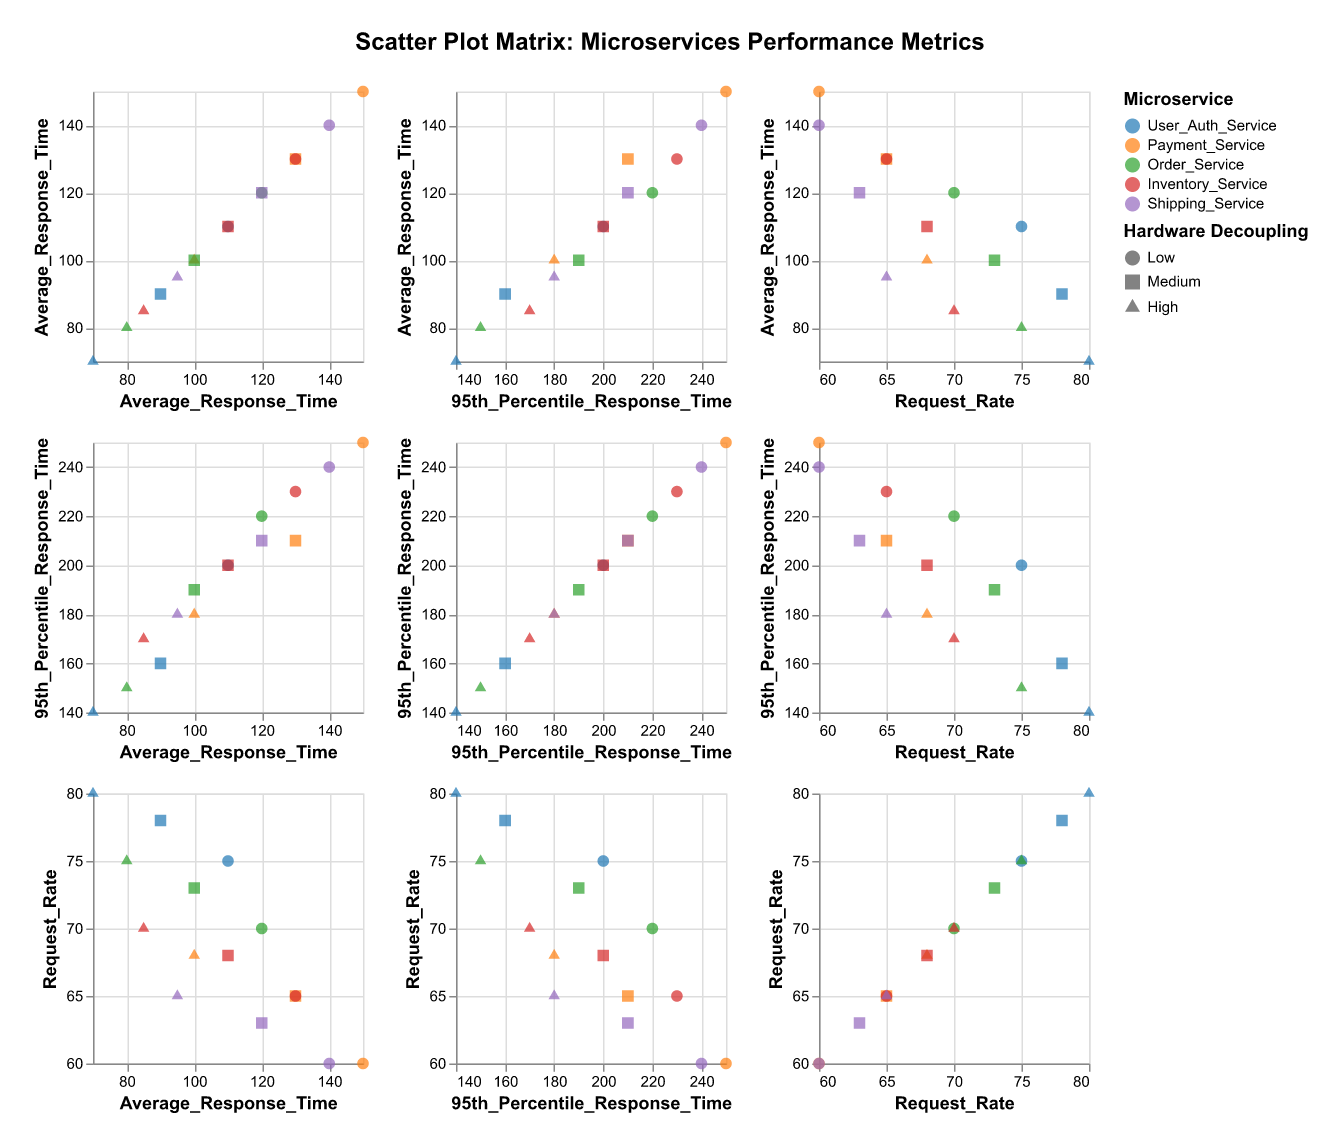What is the title of the scatter plot matrix? The title can be found at the top of the figure.
Answer: Scatter Plot Matrix: Microservices Performance Metrics Which microservice tends to have the highest average response times across different levels of hardware decoupling? By observing the scatter points for the average response time, Payment_Service generally has higher values compared to others.
Answer: Payment_Service How does the 95th percentile response time change for User_Auth_Service with increased hardware decoupling? For User_Auth_Service, observe how the 95th percentile response time points change from the "Low" to "High" decoupling levels. The visual trend shows decreasing values.
Answer: It decreases Which service demonstrates the greatest reduction in average response time from low to high hardware decoupling? Compute the difference in average response time for each service between "Low" and "High" decoupling levels. Payment_Service shows the biggest reduction (150 - 100 = 50 ms).
Answer: Payment_Service How does the request rate trend with hardware decoupling levels for Shipping_Service? Look at the shape (circle, square, triangle) and color in the request rate panel for Shipping_Service. There is a slight increase from "Low" (60) to "Medium" (63) and to "High" (65).
Answer: It increases Is there a service that shows an increase in average response time with increasing hardware decoupling levels? By looking across all services, no service shows an increasing trend in average response time. Most show a decreasing trend.
Answer: No Which service has the least variability in response times at the "High" hardware decoupling level? Compare the 95th percentile response times at "High" decoupling levels. User_Auth_Service has the smallest spread (140 - 70 = 70 ms).
Answer: User_Auth_Service Compare the request rate for Order_Service and Inventory_Service at the medium decoupling level. Which one is higher? Locate both services' points at the "Medium" decoupling level in the request rate panel. Order_Service has a request rate of 73, which higher than Inventory_Service at 68.
Answer: Order_Service How does the average response time correlate with the request rate across all services? Observe the diagonal scatter plot where average response time and request rate are plotted against each other. As average response times decrease, request rates tend to increase, indicating a negative correlation.
Answer: Negatively Which microservice has the smallest difference between its average and 95th percentile response times in the highest decoupling level? For each service at the high decoupling level, calculate the differences between the average and 95th percentile response times. User_Auth_Service has the smallest difference (140 - 70 = 70 ms).
Answer: User_Auth_Service 